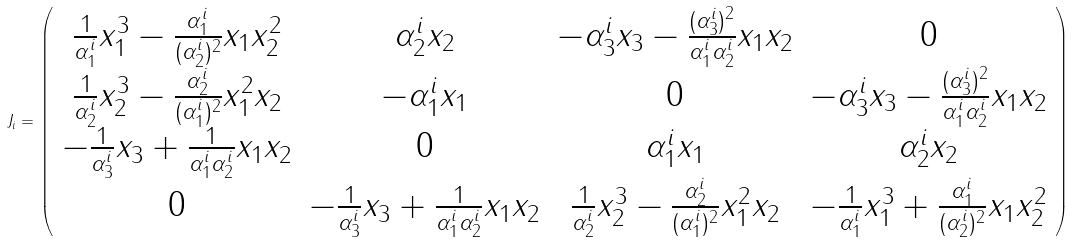Convert formula to latex. <formula><loc_0><loc_0><loc_500><loc_500>J _ { i } = \left ( \begin{array} { c c c c } \frac { 1 } { \alpha _ { 1 } ^ { i } } x _ { 1 } ^ { 3 } - \frac { \alpha _ { 1 } ^ { i } } { ( \alpha _ { 2 } ^ { i } ) ^ { 2 } } x _ { 1 } x _ { 2 } ^ { 2 } & \alpha _ { 2 } ^ { i } x _ { 2 } & - \alpha _ { 3 } ^ { i } x _ { 3 } - \frac { ( \alpha _ { 3 } ^ { i } ) ^ { 2 } } { \alpha _ { 1 } ^ { i } \alpha _ { 2 } ^ { i } } x _ { 1 } x _ { 2 } & 0 \\ \frac { 1 } { \alpha _ { 2 } ^ { i } } x _ { 2 } ^ { 3 } - \frac { \alpha _ { 2 } ^ { i } } { ( \alpha _ { 1 } ^ { i } ) ^ { 2 } } x _ { 1 } ^ { 2 } x _ { 2 } & - \alpha _ { 1 } ^ { i } x _ { 1 } & 0 & - \alpha _ { 3 } ^ { i } x _ { 3 } - \frac { ( \alpha _ { 3 } ^ { i } ) ^ { 2 } } { \alpha _ { 1 } ^ { i } \alpha _ { 2 } ^ { i } } x _ { 1 } x _ { 2 } \\ - \frac { 1 } { \alpha _ { 3 } ^ { i } } x _ { 3 } + \frac { 1 } { \alpha _ { 1 } ^ { i } \alpha _ { 2 } ^ { i } } x _ { 1 } x _ { 2 } & 0 & \alpha _ { 1 } ^ { i } x _ { 1 } & \alpha _ { 2 } ^ { i } x _ { 2 } \\ 0 & - \frac { 1 } { \alpha _ { 3 } ^ { i } } x _ { 3 } + \frac { 1 } { \alpha _ { 1 } ^ { i } \alpha _ { 2 } ^ { i } } x _ { 1 } x _ { 2 } & \frac { 1 } { \alpha _ { 2 } ^ { i } } x _ { 2 } ^ { 3 } - \frac { \alpha _ { 2 } ^ { i } } { ( \alpha _ { 1 } ^ { i } ) ^ { 2 } } x _ { 1 } ^ { 2 } x _ { 2 } & - \frac { 1 } { \alpha _ { 1 } ^ { i } } x _ { 1 } ^ { 3 } + \frac { \alpha _ { 1 } ^ { i } } { ( \alpha _ { 2 } ^ { i } ) ^ { 2 } } x _ { 1 } x _ { 2 } ^ { 2 } \end{array} \right )</formula> 